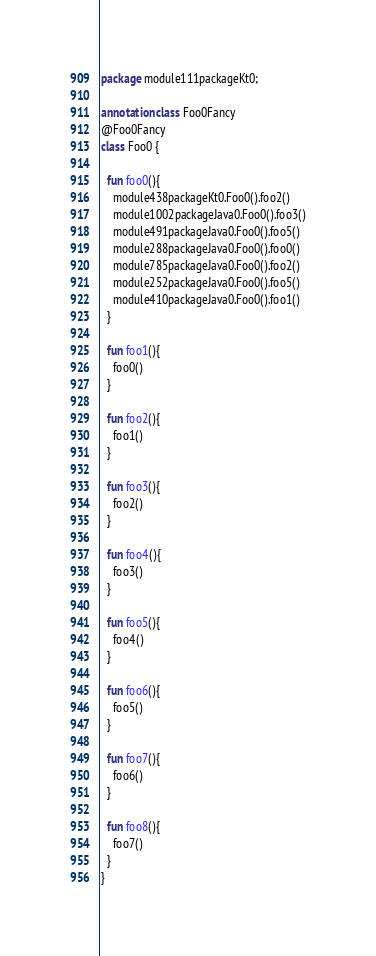<code> <loc_0><loc_0><loc_500><loc_500><_Kotlin_>package module111packageKt0;

annotation class Foo0Fancy
@Foo0Fancy
class Foo0 {

  fun foo0(){
    module438packageKt0.Foo0().foo2()
    module1002packageJava0.Foo0().foo3()
    module491packageJava0.Foo0().foo5()
    module288packageJava0.Foo0().foo0()
    module785packageJava0.Foo0().foo2()
    module252packageJava0.Foo0().foo5()
    module410packageJava0.Foo0().foo1()
  }

  fun foo1(){
    foo0()
  }

  fun foo2(){
    foo1()
  }

  fun foo3(){
    foo2()
  }

  fun foo4(){
    foo3()
  }

  fun foo5(){
    foo4()
  }

  fun foo6(){
    foo5()
  }

  fun foo7(){
    foo6()
  }

  fun foo8(){
    foo7()
  }
}</code> 